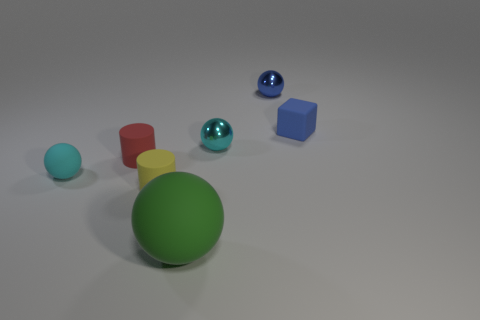Is the shape of the large green matte object the same as the small yellow object?
Provide a succinct answer. No. There is a tiny matte thing that is the same shape as the large green rubber object; what color is it?
Your response must be concise. Cyan. What number of other metal objects have the same shape as the small cyan metal thing?
Provide a short and direct response. 1. Do the cylinder that is left of the yellow object and the small ball on the left side of the big sphere have the same color?
Provide a succinct answer. No. What number of objects are either small red metallic balls or large green rubber things?
Give a very brief answer. 1. What number of large green objects are the same material as the big ball?
Ensure brevity in your answer.  0. Is the number of blue rubber things less than the number of large brown metal objects?
Provide a short and direct response. No. Is the sphere behind the tiny blue block made of the same material as the big green object?
Provide a succinct answer. No. What number of cubes are large cyan things or tiny cyan matte objects?
Your response must be concise. 0. There is a tiny rubber thing that is on the right side of the tiny red object and behind the cyan rubber object; what shape is it?
Your answer should be very brief. Cube. 